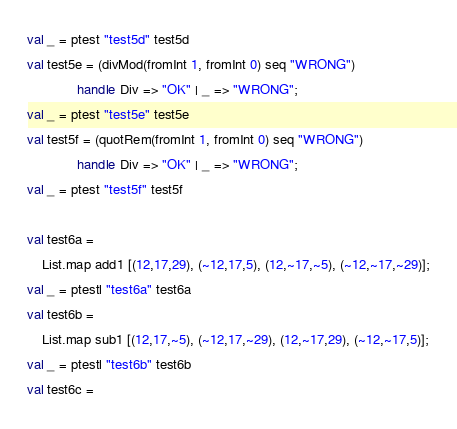Convert code to text. <code><loc_0><loc_0><loc_500><loc_500><_SML_>val _ = ptest "test5d" test5d
val test5e = (divMod(fromInt 1, fromInt 0) seq "WRONG")
             handle Div => "OK" | _ => "WRONG";
val _ = ptest "test5e" test5e
val test5f = (quotRem(fromInt 1, fromInt 0) seq "WRONG")
             handle Div => "OK" | _ => "WRONG";
val _ = ptest "test5f" test5f

val test6a = 
    List.map add1 [(12,17,29), (~12,17,5), (12,~17,~5), (~12,~17,~29)];
val _ = ptestl "test6a" test6a
val test6b = 
    List.map sub1 [(12,17,~5), (~12,17,~29), (12,~17,29), (~12,~17,5)];
val _ = ptestl "test6b" test6b
val test6c = </code> 